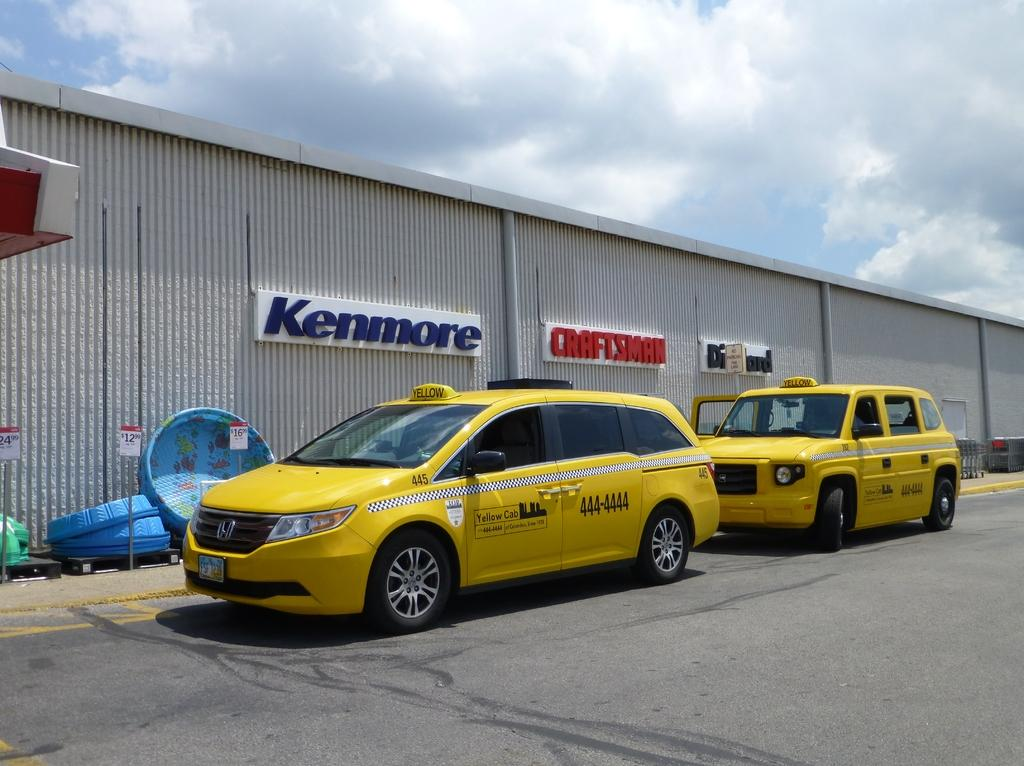<image>
Write a terse but informative summary of the picture. Two taxi cabs parked in front of a warehouse with signs for Kenmore and Craftsman 